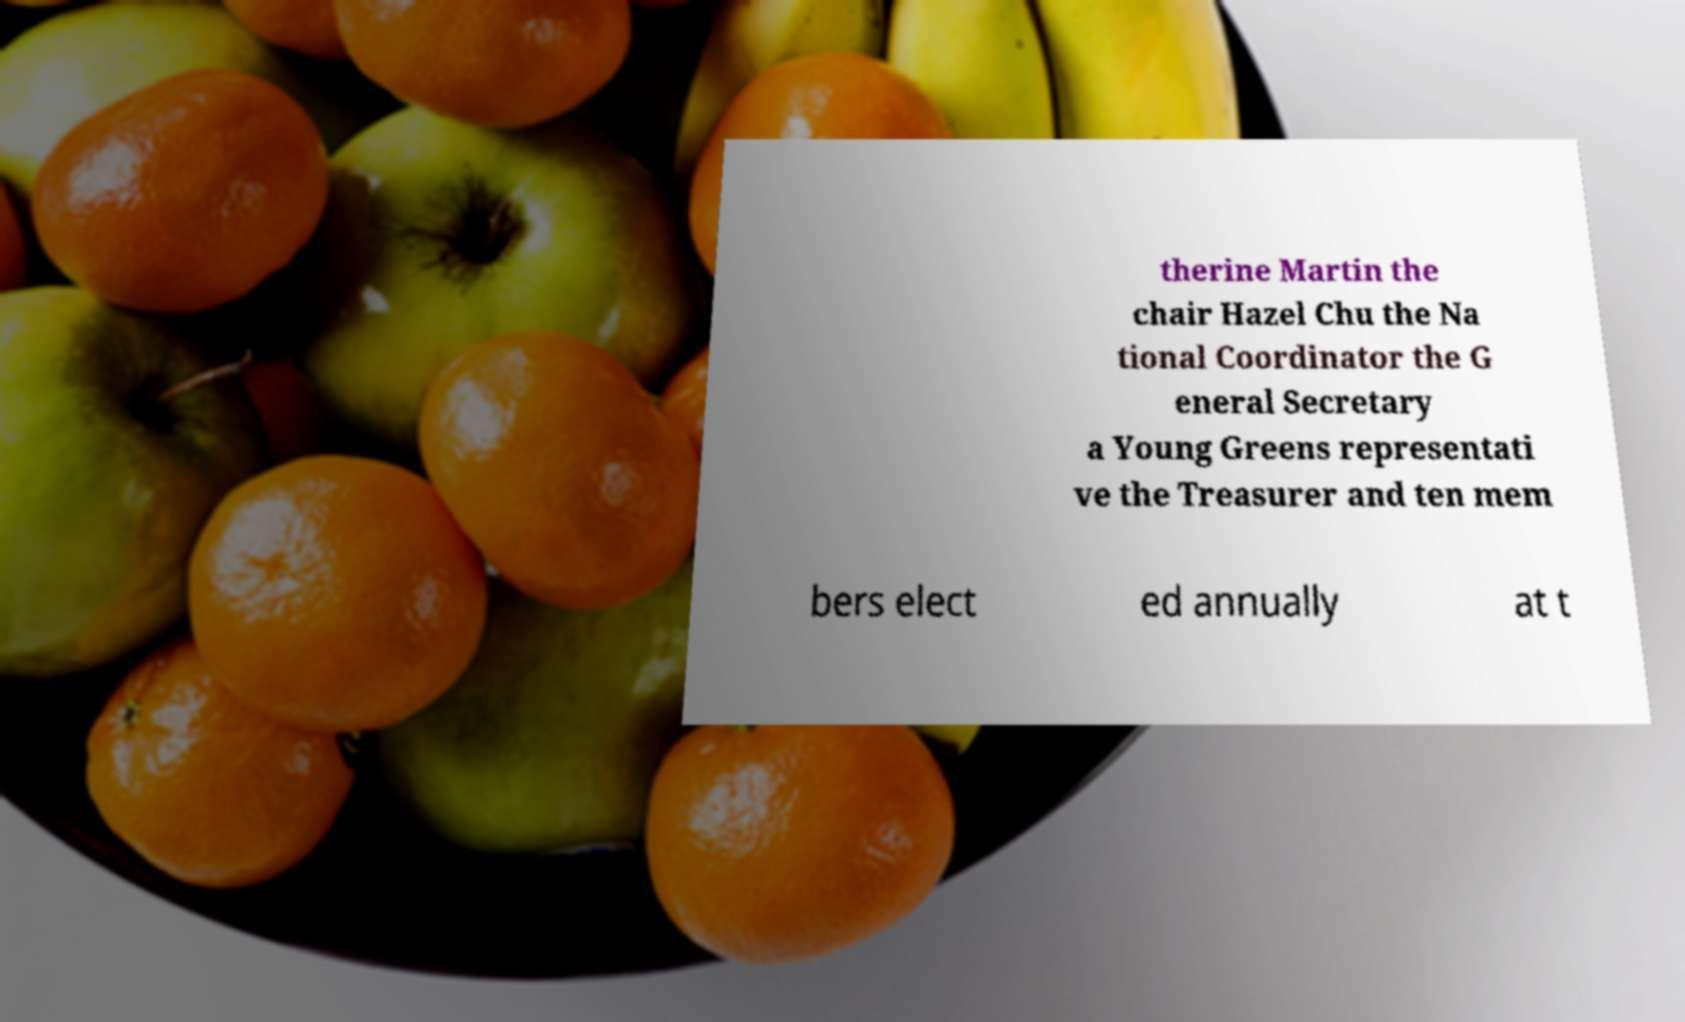Can you accurately transcribe the text from the provided image for me? therine Martin the chair Hazel Chu the Na tional Coordinator the G eneral Secretary a Young Greens representati ve the Treasurer and ten mem bers elect ed annually at t 